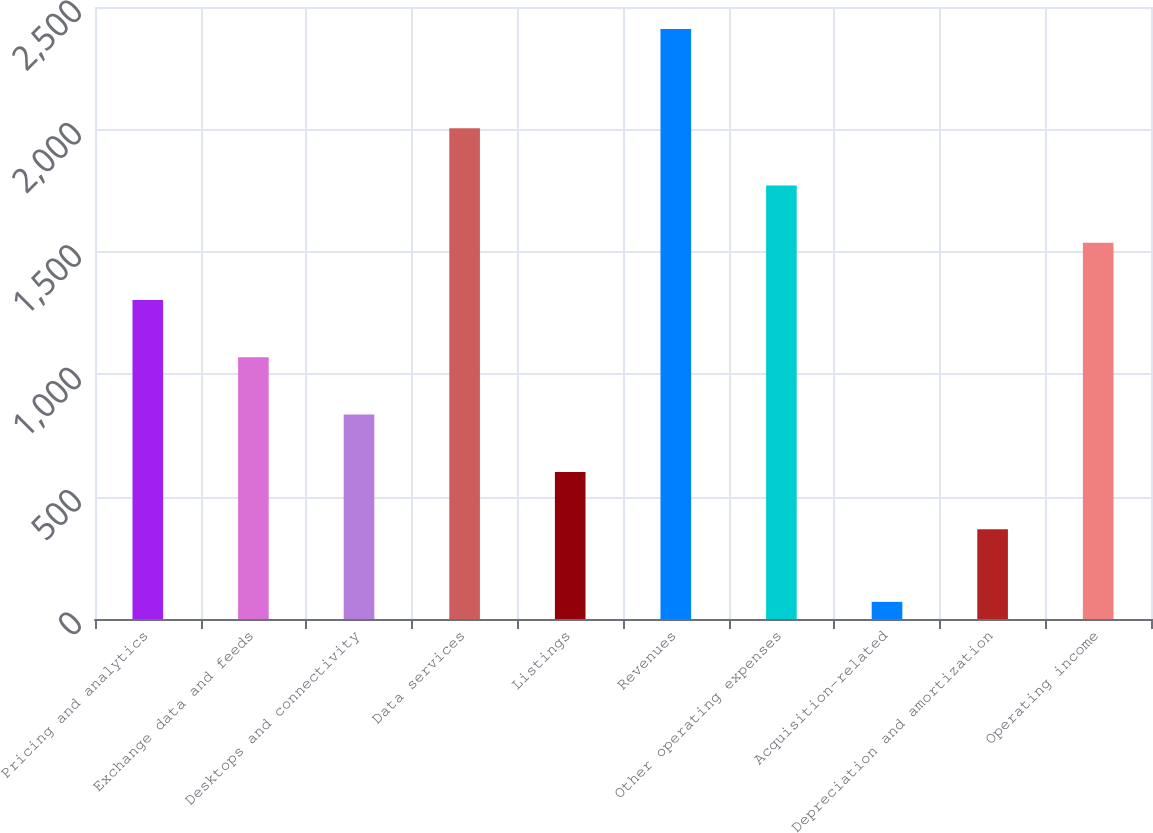Convert chart to OTSL. <chart><loc_0><loc_0><loc_500><loc_500><bar_chart><fcel>Pricing and analytics<fcel>Exchange data and feeds<fcel>Desktops and connectivity<fcel>Data services<fcel>Listings<fcel>Revenues<fcel>Other operating expenses<fcel>Acquisition-related<fcel>Depreciation and amortization<fcel>Operating income<nl><fcel>1303<fcel>1069<fcel>835<fcel>2005<fcel>601<fcel>2410<fcel>1771<fcel>70<fcel>367<fcel>1537<nl></chart> 